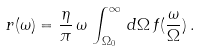<formula> <loc_0><loc_0><loc_500><loc_500>r ( \omega ) = \frac { \eta } { \pi } \, \omega \, \int _ { \Omega _ { 0 } } ^ { \infty } \, d \Omega \, f ( \frac { \omega } { \Omega } ) \, .</formula> 